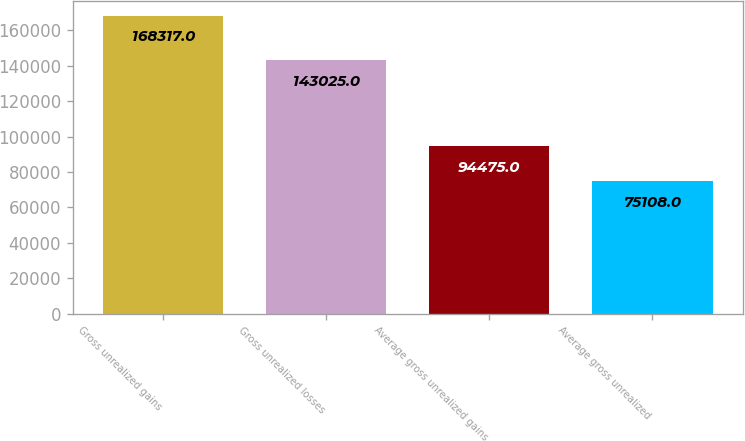Convert chart to OTSL. <chart><loc_0><loc_0><loc_500><loc_500><bar_chart><fcel>Gross unrealized gains<fcel>Gross unrealized losses<fcel>Average gross unrealized gains<fcel>Average gross unrealized<nl><fcel>168317<fcel>143025<fcel>94475<fcel>75108<nl></chart> 